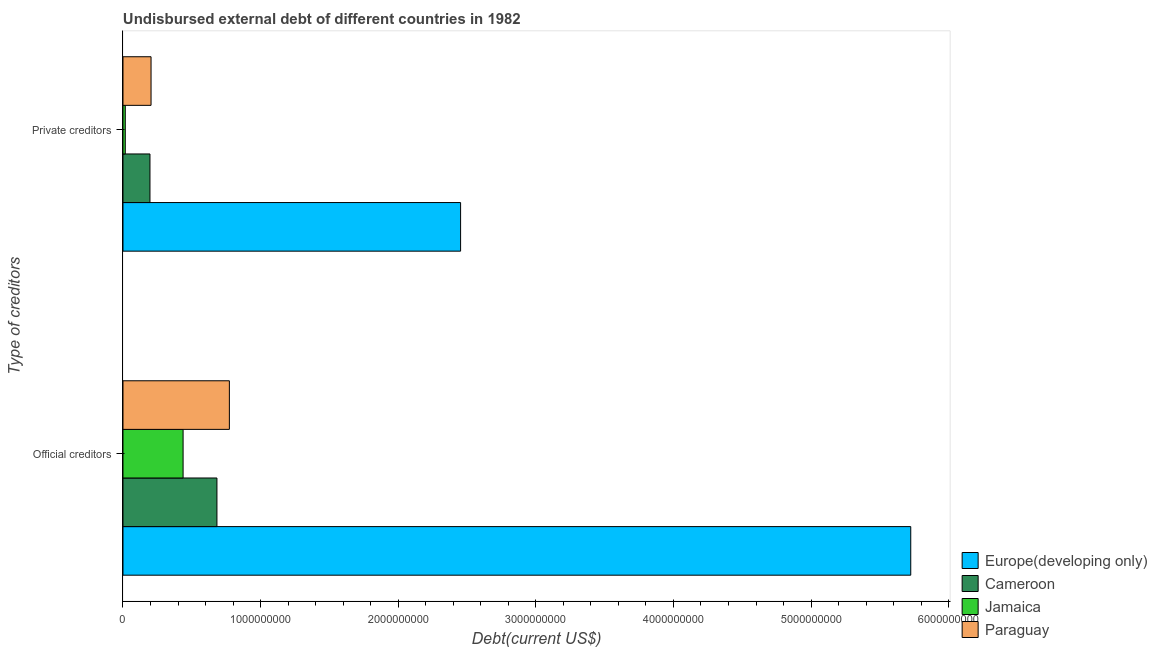How many different coloured bars are there?
Your response must be concise. 4. Are the number of bars per tick equal to the number of legend labels?
Your answer should be very brief. Yes. How many bars are there on the 2nd tick from the top?
Provide a short and direct response. 4. How many bars are there on the 2nd tick from the bottom?
Your answer should be very brief. 4. What is the label of the 2nd group of bars from the top?
Offer a terse response. Official creditors. What is the undisbursed external debt of official creditors in Paraguay?
Give a very brief answer. 7.73e+08. Across all countries, what is the maximum undisbursed external debt of official creditors?
Offer a very short reply. 5.72e+09. Across all countries, what is the minimum undisbursed external debt of private creditors?
Offer a very short reply. 1.67e+07. In which country was the undisbursed external debt of private creditors maximum?
Your answer should be very brief. Europe(developing only). In which country was the undisbursed external debt of private creditors minimum?
Give a very brief answer. Jamaica. What is the total undisbursed external debt of official creditors in the graph?
Provide a succinct answer. 7.62e+09. What is the difference between the undisbursed external debt of official creditors in Europe(developing only) and that in Paraguay?
Offer a terse response. 4.95e+09. What is the difference between the undisbursed external debt of private creditors in Cameroon and the undisbursed external debt of official creditors in Europe(developing only)?
Provide a succinct answer. -5.53e+09. What is the average undisbursed external debt of official creditors per country?
Your response must be concise. 1.90e+09. What is the difference between the undisbursed external debt of private creditors and undisbursed external debt of official creditors in Paraguay?
Offer a very short reply. -5.69e+08. In how many countries, is the undisbursed external debt of official creditors greater than 3400000000 US$?
Offer a very short reply. 1. What is the ratio of the undisbursed external debt of private creditors in Paraguay to that in Europe(developing only)?
Offer a terse response. 0.08. Is the undisbursed external debt of private creditors in Jamaica less than that in Cameroon?
Ensure brevity in your answer.  Yes. In how many countries, is the undisbursed external debt of private creditors greater than the average undisbursed external debt of private creditors taken over all countries?
Make the answer very short. 1. What does the 1st bar from the top in Private creditors represents?
Your response must be concise. Paraguay. What does the 4th bar from the bottom in Private creditors represents?
Your answer should be compact. Paraguay. What is the difference between two consecutive major ticks on the X-axis?
Offer a very short reply. 1.00e+09. What is the title of the graph?
Your answer should be very brief. Undisbursed external debt of different countries in 1982. What is the label or title of the X-axis?
Give a very brief answer. Debt(current US$). What is the label or title of the Y-axis?
Your answer should be compact. Type of creditors. What is the Debt(current US$) of Europe(developing only) in Official creditors?
Offer a very short reply. 5.72e+09. What is the Debt(current US$) of Cameroon in Official creditors?
Keep it short and to the point. 6.83e+08. What is the Debt(current US$) in Jamaica in Official creditors?
Provide a succinct answer. 4.37e+08. What is the Debt(current US$) of Paraguay in Official creditors?
Keep it short and to the point. 7.73e+08. What is the Debt(current US$) in Europe(developing only) in Private creditors?
Your answer should be compact. 2.45e+09. What is the Debt(current US$) of Cameroon in Private creditors?
Offer a very short reply. 1.96e+08. What is the Debt(current US$) in Jamaica in Private creditors?
Make the answer very short. 1.67e+07. What is the Debt(current US$) of Paraguay in Private creditors?
Ensure brevity in your answer.  2.04e+08. Across all Type of creditors, what is the maximum Debt(current US$) of Europe(developing only)?
Keep it short and to the point. 5.72e+09. Across all Type of creditors, what is the maximum Debt(current US$) of Cameroon?
Ensure brevity in your answer.  6.83e+08. Across all Type of creditors, what is the maximum Debt(current US$) in Jamaica?
Offer a very short reply. 4.37e+08. Across all Type of creditors, what is the maximum Debt(current US$) of Paraguay?
Your answer should be compact. 7.73e+08. Across all Type of creditors, what is the minimum Debt(current US$) in Europe(developing only)?
Keep it short and to the point. 2.45e+09. Across all Type of creditors, what is the minimum Debt(current US$) of Cameroon?
Your response must be concise. 1.96e+08. Across all Type of creditors, what is the minimum Debt(current US$) of Jamaica?
Your answer should be compact. 1.67e+07. Across all Type of creditors, what is the minimum Debt(current US$) in Paraguay?
Ensure brevity in your answer.  2.04e+08. What is the total Debt(current US$) in Europe(developing only) in the graph?
Provide a short and direct response. 8.18e+09. What is the total Debt(current US$) of Cameroon in the graph?
Your response must be concise. 8.79e+08. What is the total Debt(current US$) of Jamaica in the graph?
Keep it short and to the point. 4.53e+08. What is the total Debt(current US$) of Paraguay in the graph?
Provide a succinct answer. 9.77e+08. What is the difference between the Debt(current US$) in Europe(developing only) in Official creditors and that in Private creditors?
Your response must be concise. 3.27e+09. What is the difference between the Debt(current US$) in Cameroon in Official creditors and that in Private creditors?
Ensure brevity in your answer.  4.87e+08. What is the difference between the Debt(current US$) of Jamaica in Official creditors and that in Private creditors?
Offer a very short reply. 4.20e+08. What is the difference between the Debt(current US$) of Paraguay in Official creditors and that in Private creditors?
Make the answer very short. 5.69e+08. What is the difference between the Debt(current US$) in Europe(developing only) in Official creditors and the Debt(current US$) in Cameroon in Private creditors?
Provide a short and direct response. 5.53e+09. What is the difference between the Debt(current US$) of Europe(developing only) in Official creditors and the Debt(current US$) of Jamaica in Private creditors?
Make the answer very short. 5.71e+09. What is the difference between the Debt(current US$) in Europe(developing only) in Official creditors and the Debt(current US$) in Paraguay in Private creditors?
Your answer should be very brief. 5.52e+09. What is the difference between the Debt(current US$) of Cameroon in Official creditors and the Debt(current US$) of Jamaica in Private creditors?
Give a very brief answer. 6.66e+08. What is the difference between the Debt(current US$) in Cameroon in Official creditors and the Debt(current US$) in Paraguay in Private creditors?
Make the answer very short. 4.79e+08. What is the difference between the Debt(current US$) of Jamaica in Official creditors and the Debt(current US$) of Paraguay in Private creditors?
Give a very brief answer. 2.33e+08. What is the average Debt(current US$) of Europe(developing only) per Type of creditors?
Your response must be concise. 4.09e+09. What is the average Debt(current US$) of Cameroon per Type of creditors?
Offer a terse response. 4.39e+08. What is the average Debt(current US$) of Jamaica per Type of creditors?
Provide a short and direct response. 2.27e+08. What is the average Debt(current US$) in Paraguay per Type of creditors?
Your answer should be compact. 4.89e+08. What is the difference between the Debt(current US$) of Europe(developing only) and Debt(current US$) of Cameroon in Official creditors?
Provide a short and direct response. 5.04e+09. What is the difference between the Debt(current US$) in Europe(developing only) and Debt(current US$) in Jamaica in Official creditors?
Your answer should be very brief. 5.29e+09. What is the difference between the Debt(current US$) of Europe(developing only) and Debt(current US$) of Paraguay in Official creditors?
Your response must be concise. 4.95e+09. What is the difference between the Debt(current US$) of Cameroon and Debt(current US$) of Jamaica in Official creditors?
Your answer should be compact. 2.46e+08. What is the difference between the Debt(current US$) of Cameroon and Debt(current US$) of Paraguay in Official creditors?
Keep it short and to the point. -9.04e+07. What is the difference between the Debt(current US$) in Jamaica and Debt(current US$) in Paraguay in Official creditors?
Your answer should be compact. -3.36e+08. What is the difference between the Debt(current US$) of Europe(developing only) and Debt(current US$) of Cameroon in Private creditors?
Make the answer very short. 2.26e+09. What is the difference between the Debt(current US$) in Europe(developing only) and Debt(current US$) in Jamaica in Private creditors?
Your answer should be very brief. 2.44e+09. What is the difference between the Debt(current US$) of Europe(developing only) and Debt(current US$) of Paraguay in Private creditors?
Give a very brief answer. 2.25e+09. What is the difference between the Debt(current US$) in Cameroon and Debt(current US$) in Jamaica in Private creditors?
Offer a terse response. 1.79e+08. What is the difference between the Debt(current US$) in Cameroon and Debt(current US$) in Paraguay in Private creditors?
Your response must be concise. -7.78e+06. What is the difference between the Debt(current US$) of Jamaica and Debt(current US$) of Paraguay in Private creditors?
Offer a very short reply. -1.87e+08. What is the ratio of the Debt(current US$) in Europe(developing only) in Official creditors to that in Private creditors?
Offer a very short reply. 2.33. What is the ratio of the Debt(current US$) of Cameroon in Official creditors to that in Private creditors?
Keep it short and to the point. 3.48. What is the ratio of the Debt(current US$) in Jamaica in Official creditors to that in Private creditors?
Provide a succinct answer. 26.14. What is the ratio of the Debt(current US$) of Paraguay in Official creditors to that in Private creditors?
Provide a short and direct response. 3.79. What is the difference between the highest and the second highest Debt(current US$) of Europe(developing only)?
Your answer should be compact. 3.27e+09. What is the difference between the highest and the second highest Debt(current US$) of Cameroon?
Provide a succinct answer. 4.87e+08. What is the difference between the highest and the second highest Debt(current US$) of Jamaica?
Offer a terse response. 4.20e+08. What is the difference between the highest and the second highest Debt(current US$) of Paraguay?
Provide a short and direct response. 5.69e+08. What is the difference between the highest and the lowest Debt(current US$) in Europe(developing only)?
Your answer should be compact. 3.27e+09. What is the difference between the highest and the lowest Debt(current US$) in Cameroon?
Provide a succinct answer. 4.87e+08. What is the difference between the highest and the lowest Debt(current US$) of Jamaica?
Give a very brief answer. 4.20e+08. What is the difference between the highest and the lowest Debt(current US$) of Paraguay?
Your response must be concise. 5.69e+08. 